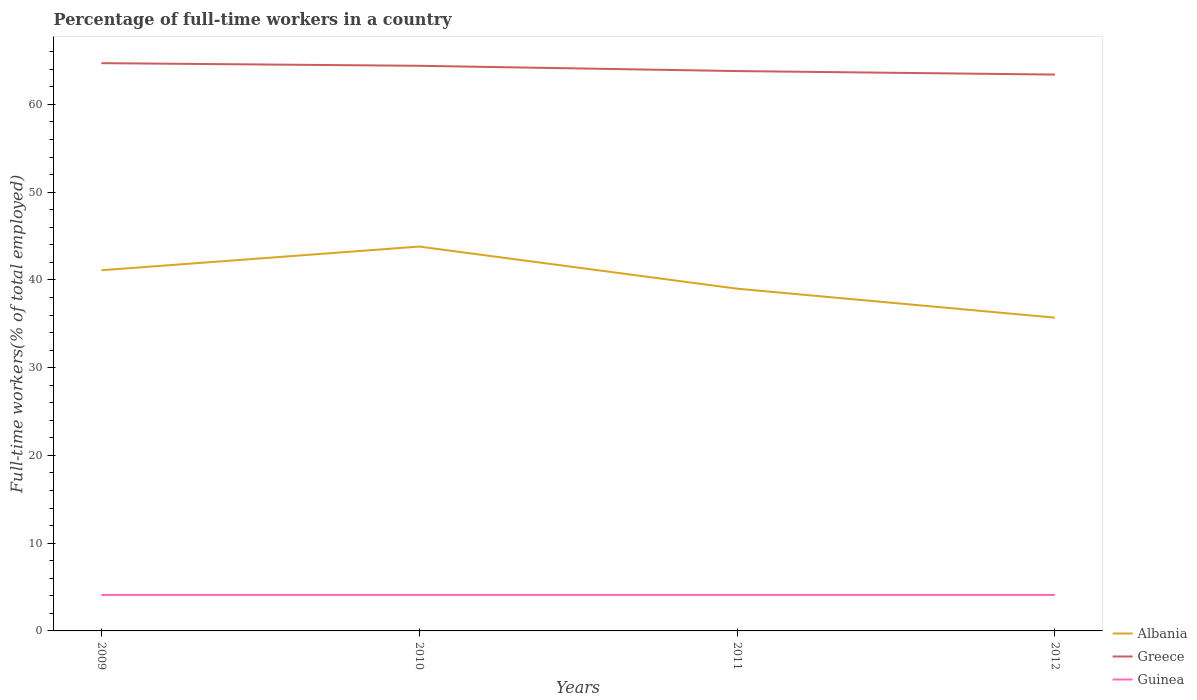Does the line corresponding to Greece intersect with the line corresponding to Albania?
Your response must be concise. No. Across all years, what is the maximum percentage of full-time workers in Albania?
Your response must be concise. 35.7. What is the total percentage of full-time workers in Guinea in the graph?
Your answer should be compact. 0. What is the difference between the highest and the second highest percentage of full-time workers in Albania?
Make the answer very short. 8.1. Does the graph contain any zero values?
Offer a terse response. No. Does the graph contain grids?
Your response must be concise. No. Where does the legend appear in the graph?
Your response must be concise. Bottom right. How are the legend labels stacked?
Provide a succinct answer. Vertical. What is the title of the graph?
Offer a very short reply. Percentage of full-time workers in a country. What is the label or title of the X-axis?
Offer a very short reply. Years. What is the label or title of the Y-axis?
Offer a terse response. Full-time workers(% of total employed). What is the Full-time workers(% of total employed) of Albania in 2009?
Your response must be concise. 41.1. What is the Full-time workers(% of total employed) in Greece in 2009?
Keep it short and to the point. 64.7. What is the Full-time workers(% of total employed) of Guinea in 2009?
Keep it short and to the point. 4.1. What is the Full-time workers(% of total employed) of Albania in 2010?
Your response must be concise. 43.8. What is the Full-time workers(% of total employed) in Greece in 2010?
Offer a very short reply. 64.4. What is the Full-time workers(% of total employed) of Guinea in 2010?
Your response must be concise. 4.1. What is the Full-time workers(% of total employed) in Albania in 2011?
Offer a very short reply. 39. What is the Full-time workers(% of total employed) of Greece in 2011?
Keep it short and to the point. 63.8. What is the Full-time workers(% of total employed) in Guinea in 2011?
Your response must be concise. 4.1. What is the Full-time workers(% of total employed) in Albania in 2012?
Provide a succinct answer. 35.7. What is the Full-time workers(% of total employed) of Greece in 2012?
Your answer should be very brief. 63.4. What is the Full-time workers(% of total employed) of Guinea in 2012?
Your response must be concise. 4.1. Across all years, what is the maximum Full-time workers(% of total employed) of Albania?
Provide a short and direct response. 43.8. Across all years, what is the maximum Full-time workers(% of total employed) of Greece?
Give a very brief answer. 64.7. Across all years, what is the maximum Full-time workers(% of total employed) of Guinea?
Offer a very short reply. 4.1. Across all years, what is the minimum Full-time workers(% of total employed) of Albania?
Give a very brief answer. 35.7. Across all years, what is the minimum Full-time workers(% of total employed) of Greece?
Ensure brevity in your answer.  63.4. Across all years, what is the minimum Full-time workers(% of total employed) in Guinea?
Offer a terse response. 4.1. What is the total Full-time workers(% of total employed) in Albania in the graph?
Give a very brief answer. 159.6. What is the total Full-time workers(% of total employed) in Greece in the graph?
Your answer should be very brief. 256.3. What is the total Full-time workers(% of total employed) in Guinea in the graph?
Provide a succinct answer. 16.4. What is the difference between the Full-time workers(% of total employed) in Albania in 2009 and that in 2010?
Offer a very short reply. -2.7. What is the difference between the Full-time workers(% of total employed) of Guinea in 2009 and that in 2010?
Offer a terse response. 0. What is the difference between the Full-time workers(% of total employed) of Guinea in 2009 and that in 2011?
Provide a succinct answer. 0. What is the difference between the Full-time workers(% of total employed) in Albania in 2009 and that in 2012?
Ensure brevity in your answer.  5.4. What is the difference between the Full-time workers(% of total employed) in Greece in 2009 and that in 2012?
Ensure brevity in your answer.  1.3. What is the difference between the Full-time workers(% of total employed) in Albania in 2010 and that in 2011?
Offer a very short reply. 4.8. What is the difference between the Full-time workers(% of total employed) of Greece in 2010 and that in 2011?
Keep it short and to the point. 0.6. What is the difference between the Full-time workers(% of total employed) of Guinea in 2010 and that in 2012?
Provide a short and direct response. 0. What is the difference between the Full-time workers(% of total employed) of Albania in 2011 and that in 2012?
Your answer should be very brief. 3.3. What is the difference between the Full-time workers(% of total employed) of Greece in 2011 and that in 2012?
Ensure brevity in your answer.  0.4. What is the difference between the Full-time workers(% of total employed) of Guinea in 2011 and that in 2012?
Keep it short and to the point. 0. What is the difference between the Full-time workers(% of total employed) of Albania in 2009 and the Full-time workers(% of total employed) of Greece in 2010?
Offer a very short reply. -23.3. What is the difference between the Full-time workers(% of total employed) in Albania in 2009 and the Full-time workers(% of total employed) in Guinea in 2010?
Your answer should be compact. 37. What is the difference between the Full-time workers(% of total employed) in Greece in 2009 and the Full-time workers(% of total employed) in Guinea in 2010?
Provide a succinct answer. 60.6. What is the difference between the Full-time workers(% of total employed) in Albania in 2009 and the Full-time workers(% of total employed) in Greece in 2011?
Your response must be concise. -22.7. What is the difference between the Full-time workers(% of total employed) in Albania in 2009 and the Full-time workers(% of total employed) in Guinea in 2011?
Your answer should be very brief. 37. What is the difference between the Full-time workers(% of total employed) of Greece in 2009 and the Full-time workers(% of total employed) of Guinea in 2011?
Ensure brevity in your answer.  60.6. What is the difference between the Full-time workers(% of total employed) of Albania in 2009 and the Full-time workers(% of total employed) of Greece in 2012?
Your answer should be compact. -22.3. What is the difference between the Full-time workers(% of total employed) in Greece in 2009 and the Full-time workers(% of total employed) in Guinea in 2012?
Your response must be concise. 60.6. What is the difference between the Full-time workers(% of total employed) of Albania in 2010 and the Full-time workers(% of total employed) of Greece in 2011?
Your answer should be very brief. -20. What is the difference between the Full-time workers(% of total employed) of Albania in 2010 and the Full-time workers(% of total employed) of Guinea in 2011?
Your answer should be compact. 39.7. What is the difference between the Full-time workers(% of total employed) of Greece in 2010 and the Full-time workers(% of total employed) of Guinea in 2011?
Offer a terse response. 60.3. What is the difference between the Full-time workers(% of total employed) in Albania in 2010 and the Full-time workers(% of total employed) in Greece in 2012?
Give a very brief answer. -19.6. What is the difference between the Full-time workers(% of total employed) of Albania in 2010 and the Full-time workers(% of total employed) of Guinea in 2012?
Your answer should be very brief. 39.7. What is the difference between the Full-time workers(% of total employed) of Greece in 2010 and the Full-time workers(% of total employed) of Guinea in 2012?
Ensure brevity in your answer.  60.3. What is the difference between the Full-time workers(% of total employed) of Albania in 2011 and the Full-time workers(% of total employed) of Greece in 2012?
Provide a succinct answer. -24.4. What is the difference between the Full-time workers(% of total employed) of Albania in 2011 and the Full-time workers(% of total employed) of Guinea in 2012?
Your answer should be compact. 34.9. What is the difference between the Full-time workers(% of total employed) of Greece in 2011 and the Full-time workers(% of total employed) of Guinea in 2012?
Give a very brief answer. 59.7. What is the average Full-time workers(% of total employed) of Albania per year?
Ensure brevity in your answer.  39.9. What is the average Full-time workers(% of total employed) of Greece per year?
Give a very brief answer. 64.08. What is the average Full-time workers(% of total employed) in Guinea per year?
Keep it short and to the point. 4.1. In the year 2009, what is the difference between the Full-time workers(% of total employed) of Albania and Full-time workers(% of total employed) of Greece?
Your answer should be compact. -23.6. In the year 2009, what is the difference between the Full-time workers(% of total employed) of Albania and Full-time workers(% of total employed) of Guinea?
Your response must be concise. 37. In the year 2009, what is the difference between the Full-time workers(% of total employed) of Greece and Full-time workers(% of total employed) of Guinea?
Ensure brevity in your answer.  60.6. In the year 2010, what is the difference between the Full-time workers(% of total employed) in Albania and Full-time workers(% of total employed) in Greece?
Offer a very short reply. -20.6. In the year 2010, what is the difference between the Full-time workers(% of total employed) of Albania and Full-time workers(% of total employed) of Guinea?
Provide a short and direct response. 39.7. In the year 2010, what is the difference between the Full-time workers(% of total employed) in Greece and Full-time workers(% of total employed) in Guinea?
Your answer should be compact. 60.3. In the year 2011, what is the difference between the Full-time workers(% of total employed) of Albania and Full-time workers(% of total employed) of Greece?
Ensure brevity in your answer.  -24.8. In the year 2011, what is the difference between the Full-time workers(% of total employed) of Albania and Full-time workers(% of total employed) of Guinea?
Give a very brief answer. 34.9. In the year 2011, what is the difference between the Full-time workers(% of total employed) in Greece and Full-time workers(% of total employed) in Guinea?
Provide a short and direct response. 59.7. In the year 2012, what is the difference between the Full-time workers(% of total employed) in Albania and Full-time workers(% of total employed) in Greece?
Your answer should be very brief. -27.7. In the year 2012, what is the difference between the Full-time workers(% of total employed) in Albania and Full-time workers(% of total employed) in Guinea?
Provide a short and direct response. 31.6. In the year 2012, what is the difference between the Full-time workers(% of total employed) of Greece and Full-time workers(% of total employed) of Guinea?
Your answer should be very brief. 59.3. What is the ratio of the Full-time workers(% of total employed) of Albania in 2009 to that in 2010?
Provide a short and direct response. 0.94. What is the ratio of the Full-time workers(% of total employed) in Greece in 2009 to that in 2010?
Your answer should be compact. 1. What is the ratio of the Full-time workers(% of total employed) in Albania in 2009 to that in 2011?
Offer a terse response. 1.05. What is the ratio of the Full-time workers(% of total employed) of Greece in 2009 to that in 2011?
Your answer should be compact. 1.01. What is the ratio of the Full-time workers(% of total employed) of Albania in 2009 to that in 2012?
Offer a terse response. 1.15. What is the ratio of the Full-time workers(% of total employed) in Greece in 2009 to that in 2012?
Your response must be concise. 1.02. What is the ratio of the Full-time workers(% of total employed) in Guinea in 2009 to that in 2012?
Offer a terse response. 1. What is the ratio of the Full-time workers(% of total employed) in Albania in 2010 to that in 2011?
Offer a very short reply. 1.12. What is the ratio of the Full-time workers(% of total employed) in Greece in 2010 to that in 2011?
Keep it short and to the point. 1.01. What is the ratio of the Full-time workers(% of total employed) of Guinea in 2010 to that in 2011?
Provide a short and direct response. 1. What is the ratio of the Full-time workers(% of total employed) of Albania in 2010 to that in 2012?
Provide a succinct answer. 1.23. What is the ratio of the Full-time workers(% of total employed) of Greece in 2010 to that in 2012?
Offer a terse response. 1.02. What is the ratio of the Full-time workers(% of total employed) of Guinea in 2010 to that in 2012?
Keep it short and to the point. 1. What is the ratio of the Full-time workers(% of total employed) of Albania in 2011 to that in 2012?
Offer a terse response. 1.09. What is the ratio of the Full-time workers(% of total employed) of Greece in 2011 to that in 2012?
Make the answer very short. 1.01. What is the ratio of the Full-time workers(% of total employed) in Guinea in 2011 to that in 2012?
Offer a terse response. 1. What is the difference between the highest and the second highest Full-time workers(% of total employed) of Guinea?
Provide a short and direct response. 0. 